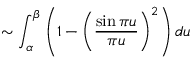Convert formula to latex. <formula><loc_0><loc_0><loc_500><loc_500>\sim \int _ { \alpha } ^ { \beta } \left ( 1 - { \left ( } { \frac { \sin { \pi u } } { \pi u } } { \right ) } ^ { 2 } \right ) d u</formula> 